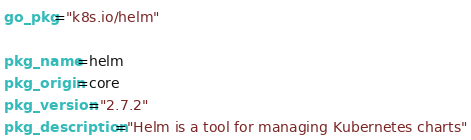<code> <loc_0><loc_0><loc_500><loc_500><_Bash_>go_pkg="k8s.io/helm"

pkg_name=helm
pkg_origin=core
pkg_version="2.7.2"
pkg_description="Helm is a tool for managing Kubernetes charts"</code> 